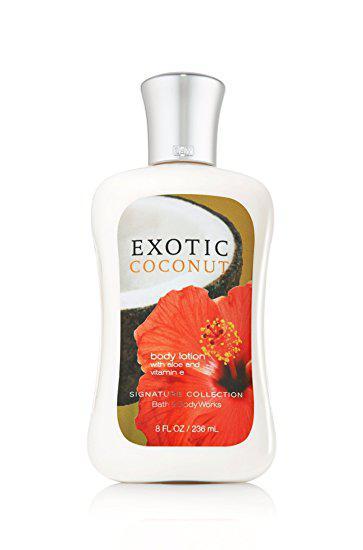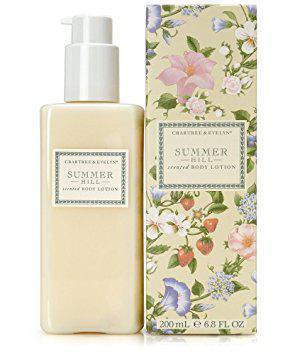The first image is the image on the left, the second image is the image on the right. Considering the images on both sides, is "There are exactly two objects standing." valid? Answer yes or no. No. The first image is the image on the left, the second image is the image on the right. For the images displayed, is the sentence "The left image shows a bottle of white lotion." factually correct? Answer yes or no. Yes. 